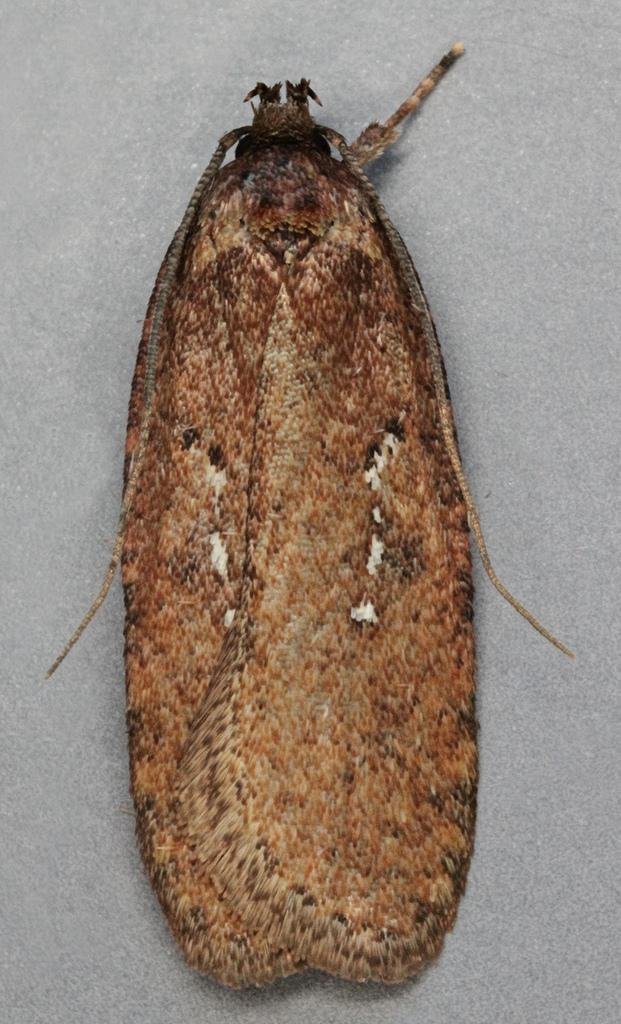What type of creature can be seen in the image? There is an insect in the image. Where is the insect located in the image? The insect is on a surface. What type of lake can be seen in the image? There is no lake present in the image; it features an insect on a surface. How is the insect's distribution being managed in the image? The image does not show any distribution management for the insect; it simply depicts the insect on a surface. 